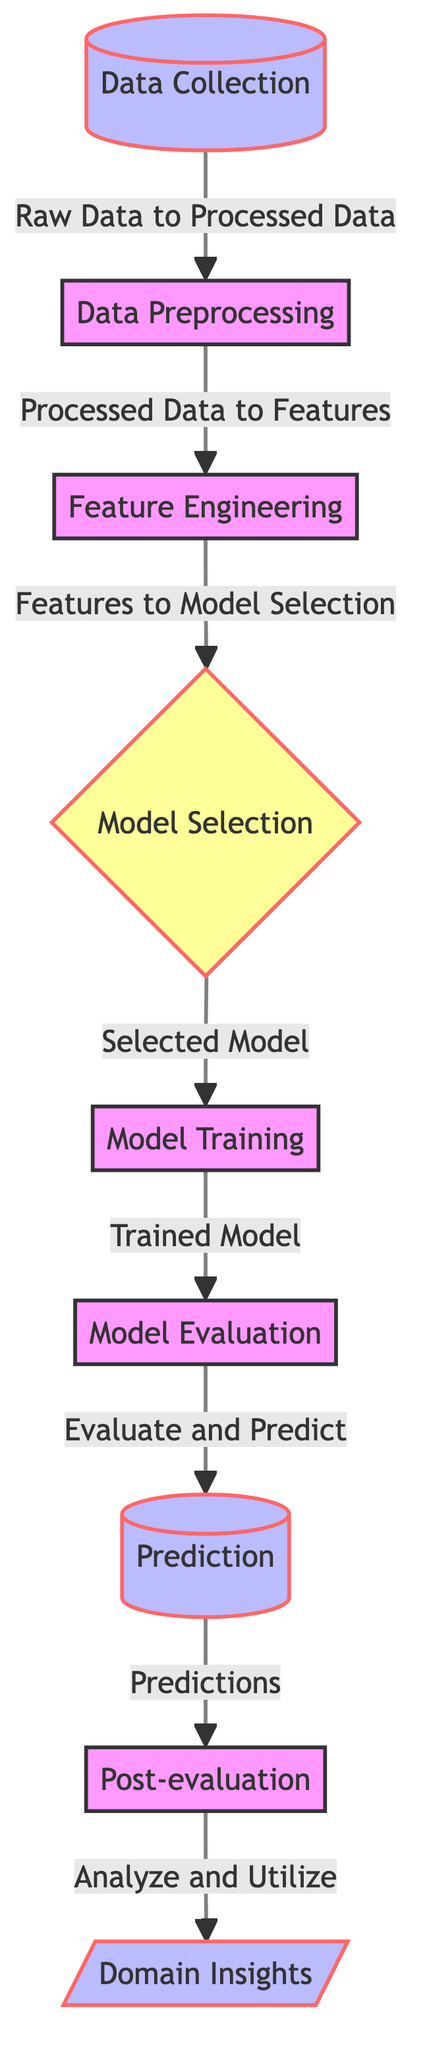What is the first step in the process? The diagram begins with the "Data Collection" node, which represents the initial stage where raw data is gathered.
Answer: Data Collection How many nodes are in the diagram? By counting each distinct step or decision point in the flowchart, there are a total of 9 nodes visible in the diagram.
Answer: 9 What is the last step before generating predictions? The last step before predictions is "Model Evaluation", which follows "Model Training" in the workflow to assess the model’s performance.
Answer: Model Evaluation Which node comes after "Data Preprocessing"? After "Data Preprocessing", the next step in the sequence is "Feature Engineering", where features are created for model training.
Answer: Feature Engineering What shape is the “Model Selection” node? The "Model Selection" node is depicted as a diamond shape, which indicates a decision point in the diagram where options are evaluated.
Answer: Diamond Which node is labeled as "Domain Insights"? The last node on the right side of the diagram, after "Post-evaluation", is labeled as "Domain Insights", indicating the utilization of the analysis performed.
Answer: Domain Insights Which process occurs directly after "Model Training"? After "Model Training", the process that follows is "Model Evaluation", where the trained model is assessed for its performance and accuracy.
Answer: Model Evaluation What is the purpose of the “Post-evaluation” step? The "Post-evaluation" step serves to analyze and utilize the predictions made by the model in a practical context, drawing insights from the results.
Answer: Analyze and Utilize What type of node is “Model Selection”? The "Model Selection" node is a decision node, indicated by its diamond shape, where the decision regarding which model to use is made.
Answer: Decision 